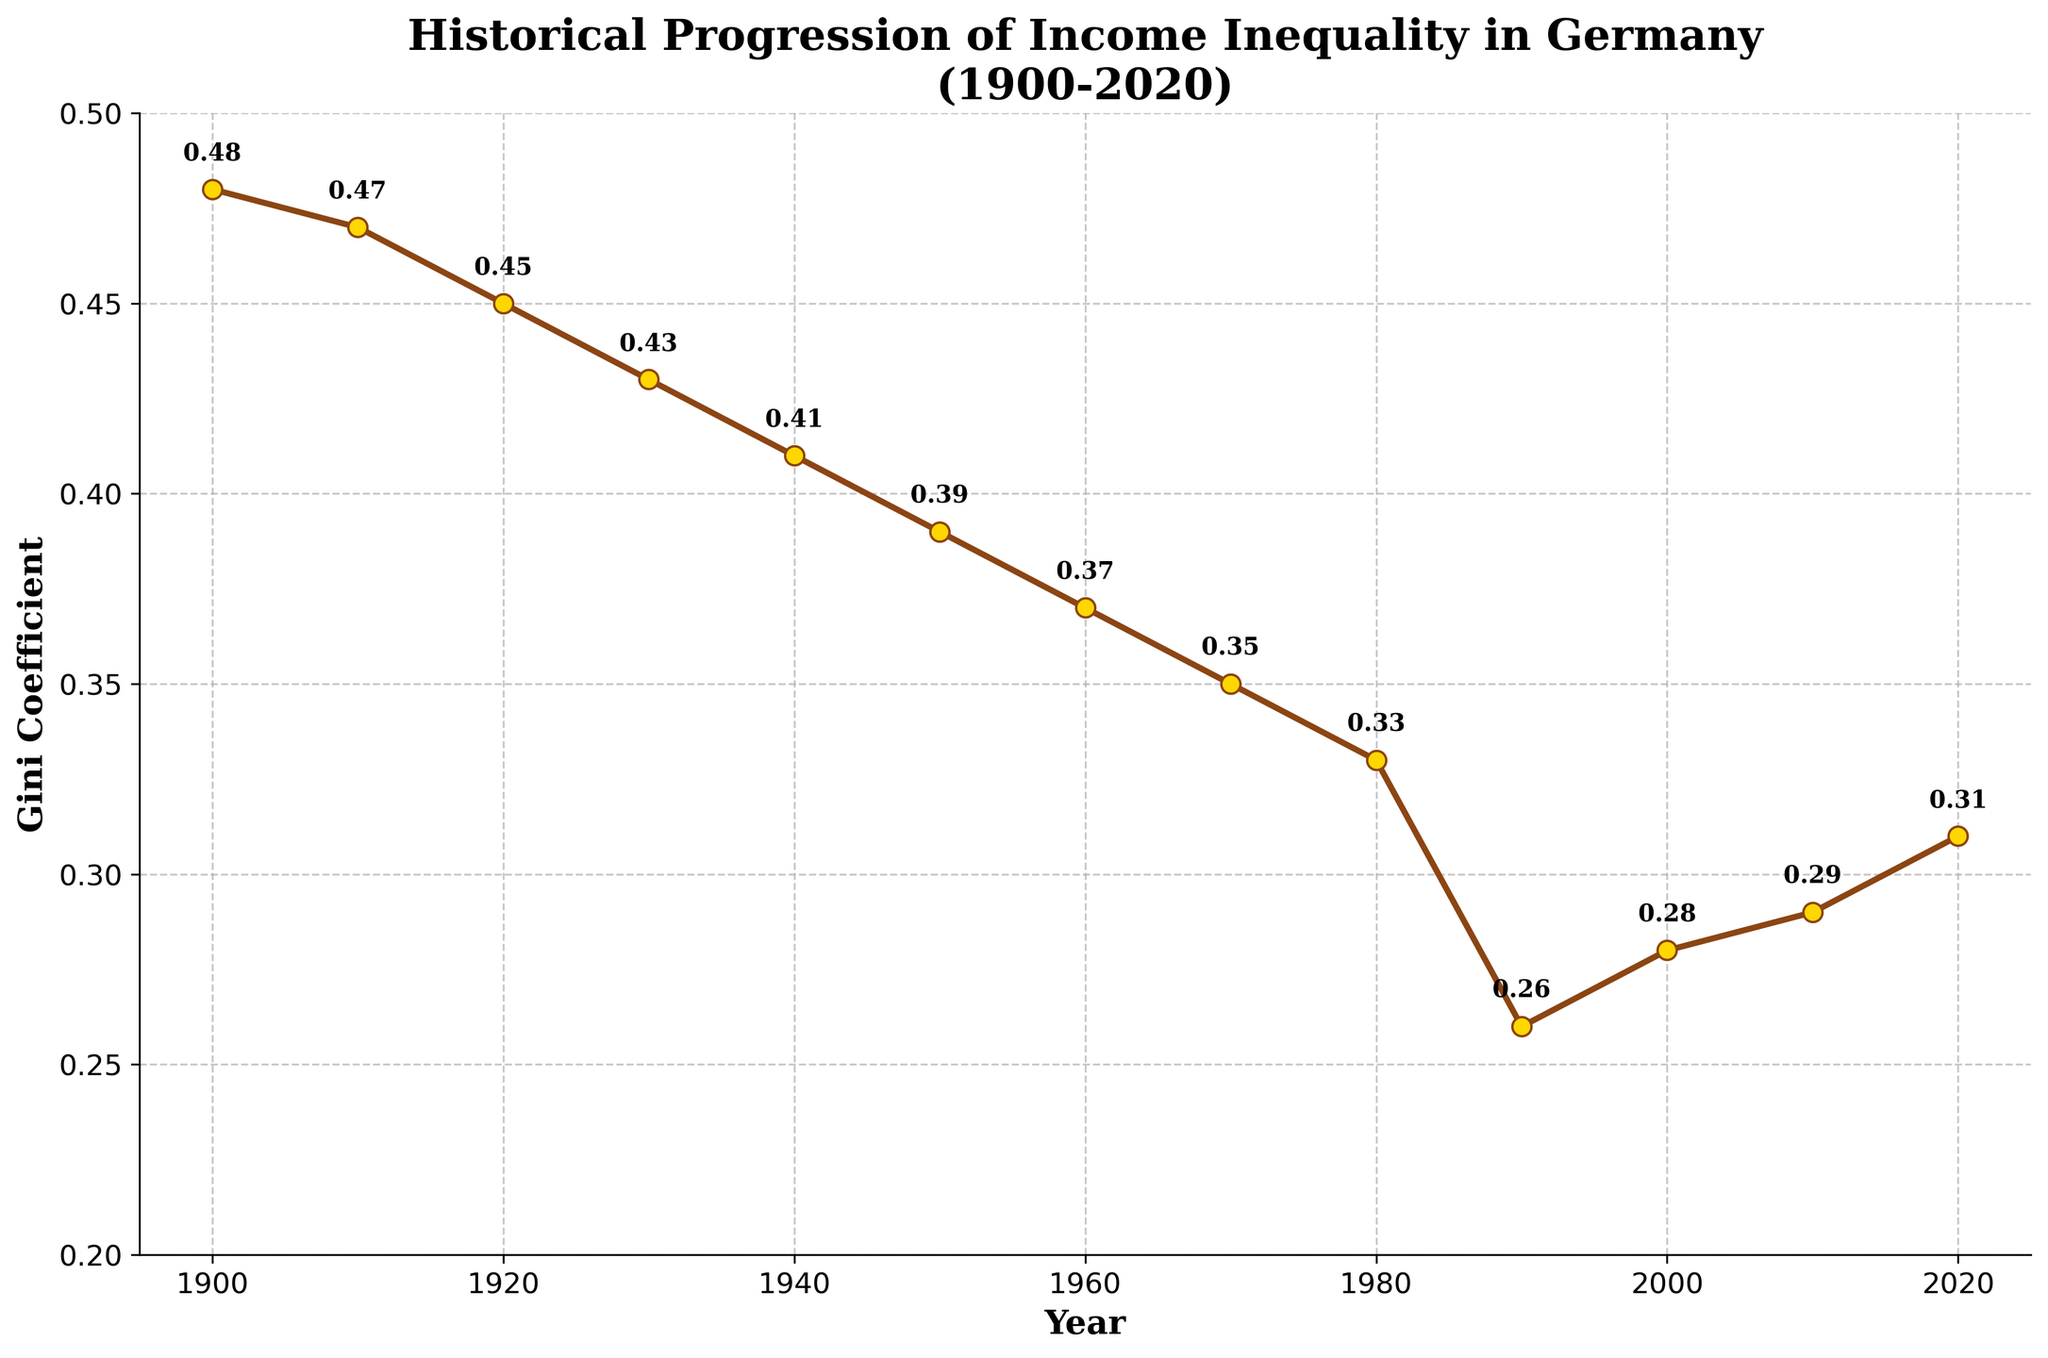What was the Gini coefficient in 1940? Look at the value on the y-axis corresponding to the year 1940.
Answer: 0.41 In which decade did Germany experience the largest decrease in income inequality, as measured by the Gini coefficient? By comparing the drop in Gini coefficients across decades, the largest decrease is between 1980 (0.33) and 1990 (0.26).
Answer: Between 1980 and 1990 What is the trend in income inequality from 1900 to 2020 as shown by the Gini coefficient? Observe the overall pattern: the Gini coefficient decreases from 1900 to 1990, and then increases slightly from 2000 to 2020.
Answer: Decreasing until 1990, then increasing slowly How much did the Gini coefficient change between 1910 and 1950? Subtract the Gini coefficient value in 1950 from that in 1910: 0.47 - 0.39.
Answer: 0.08 Which year demonstrated the lowest income inequality, based on the Gini coefficient? Identify the lowest point on the y-axis: the lowest Gini coefficient value is in 1990.
Answer: 1990 By how much did the Gini coefficient increase from 2000 to 2020? Subtract the Gini coefficient in 2000 from that in 2020: 0.31 - 0.28.
Answer: 0.03 Compare the Gini coefficient values in 1930 and 2020. Which year had a higher measure of income inequality and by how much? The Gini coefficient in 1930 is 0.43, and in 2020 it is 0.31. Subtract the 2020 value from the 1930 value: 0.43 - 0.31.
Answer: 1930 by 0.12 What is the average Gini coefficient from 1950 to 2000? Sum the Gini coefficients from 1950 (0.39), 1960 (0.37), 1970 (0.35), 1980 (0.33), 1990 (0.26), 2000 (0.28), and divide by 6. (0.39 + 0.37 + 0.35 + 0.33 + 0.26 + 0.28)/6 = 1.98/6.
Answer: 0.33 